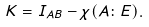<formula> <loc_0><loc_0><loc_500><loc_500>K = I _ { A B } - \chi ( A \colon E ) .</formula> 